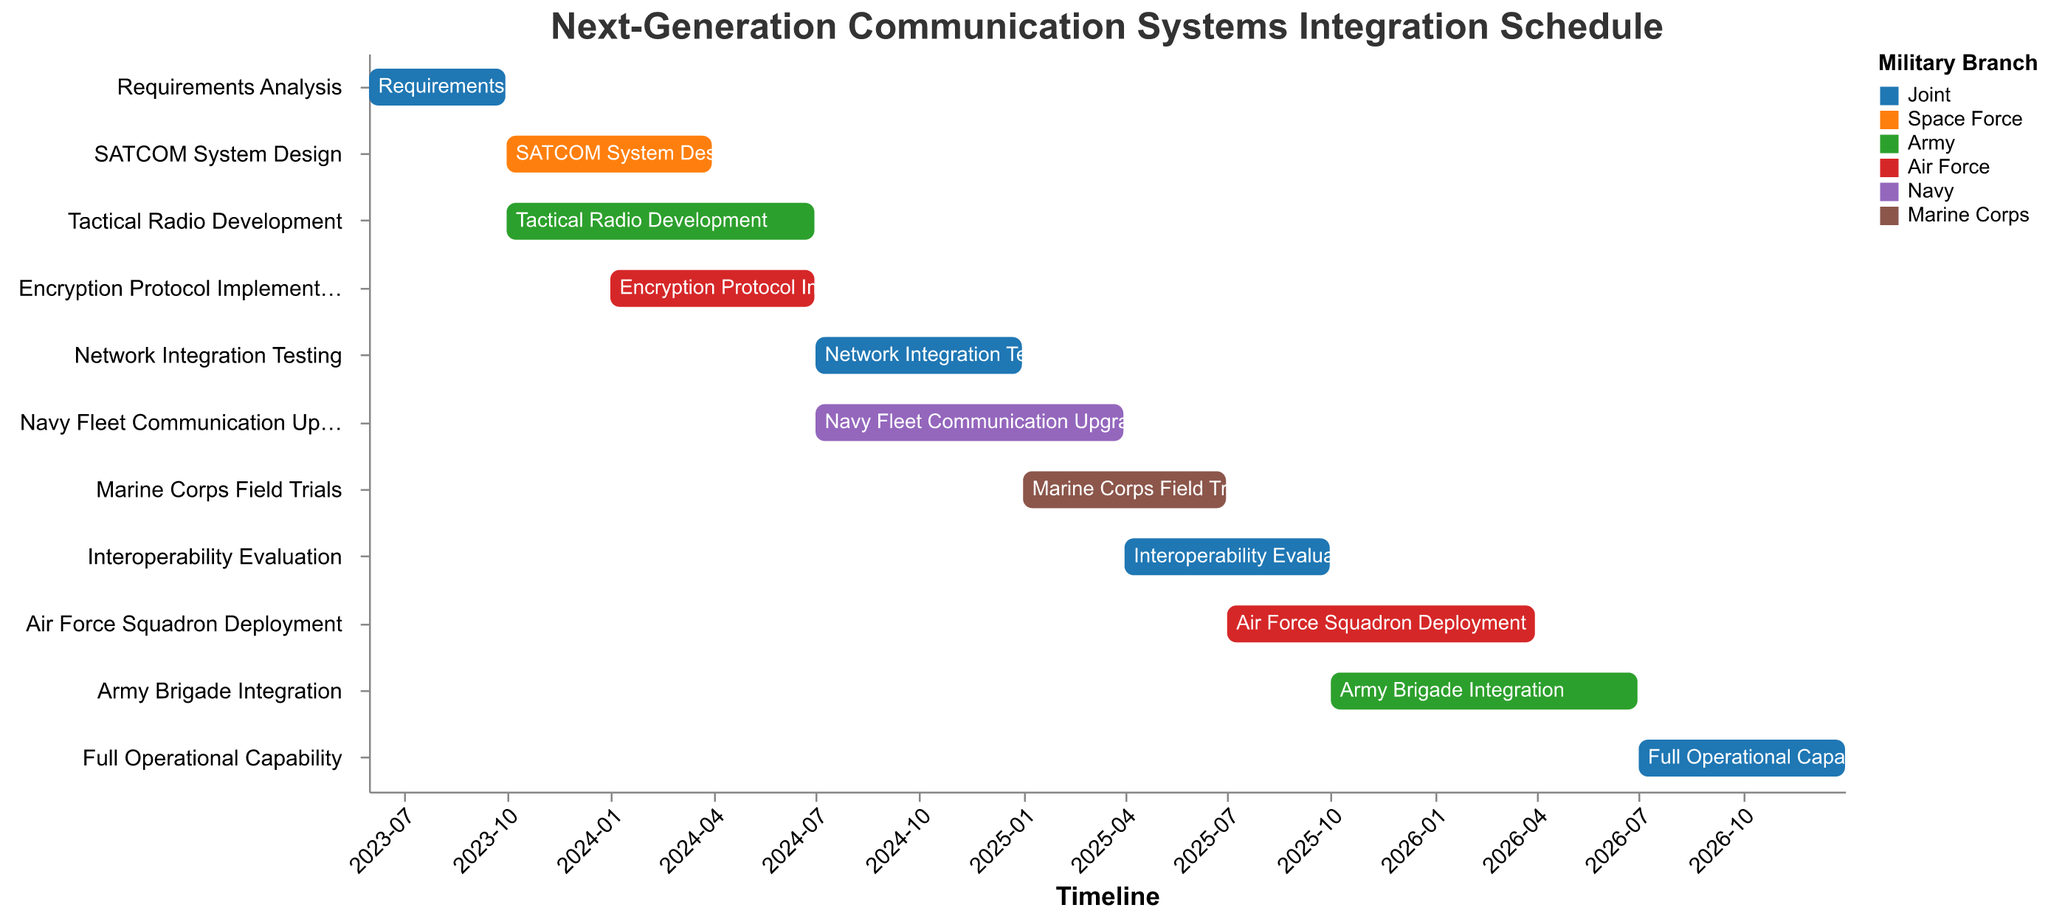What is the title of the Gantt chart? The title is displayed at the top of the Gantt chart. It helps provide context for what the chart is about.
Answer: Next-Generation Communication Systems Integration Schedule Which task is handled by the Space Force, and when does it start and end? The color and label associated with "Space Force" help identify the specific task. According to the chart legend, the "SATCOM System Design" task falls under the Space Force.
Answer: SATCOM System Design, 2023-10-01 to 2024-03-31 How long does the Army Brigade Integration take, and which branch is responsible for it? To find this, locate the "Army Brigade Integration" task on the y-axis, and observe its start and end dates on the x-axis. The difference between the start and end dates gives the duration.
Answer: Army, 9 months Which tasks have the "Joint" operation branch associated with them? Referring to the legend and matching the color associated with the "Joint" branch, then listing all tasks with that color.
Answer: Requirements Analysis, Network Integration Testing, Interoperability Evaluation, Full Operational Capability When does the Encryption Protocol Implementation start and end? Locate "Encryption Protocol Implementation" on the y-axis and refer to its corresponding timeline on the x-axis to get the start and end dates.
Answer: 2024-01-01 to 2024-06-30 Which branch has the most tasks assigned to it, and what are they? By checking the color coding of tasks and counting the number of tasks per branch, you can determine which branch has the most tasks.
Answer: Joint: Requirements Analysis, Network Integration Testing, Interoperability Evaluation, Full Operational Capability Do any tasks overlap with the Marine Corps Field Trials? If so, which ones? Locate "Marine Corps Field Trials" on the y-axis, then look for other tasks that share overlapping timelines on the x-axis.
Answer: Interoperability Evaluation, Navy Fleet Communication Upgrade, Air Force Squadron Deployment Which task lasts the longest, and how many months does it span? Determine the duration of each task by subtracting the start date from the end date, then compare to find the longest one.
Answer: Army Brigade Integration, 9 months What is the final task before achieving Full Operational Capability, and when does it end? Identify the last task listed before "Full Operational Capability" and check its end date.
Answer: Army Brigade Integration, 2026-06-30 Which tasks are scheduled to run during the entirety of 2025? Check each task's start and end dates to see if they cover all months of 2025.
Answer: Marine Corps Field Trials, Interoperability Evaluation, Air Force Squadron Deployment 